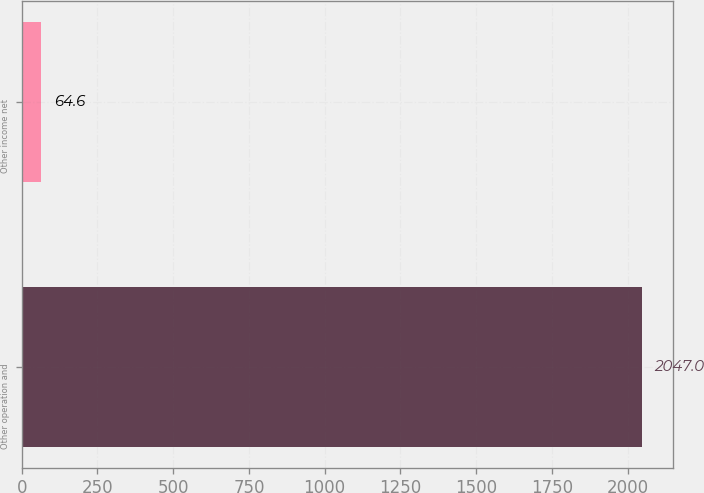<chart> <loc_0><loc_0><loc_500><loc_500><bar_chart><fcel>Other operation and<fcel>Other income net<nl><fcel>2047<fcel>64.6<nl></chart> 